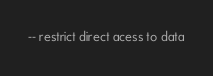Convert code to text. <code><loc_0><loc_0><loc_500><loc_500><_SQL_>-- restrict direct acess to data</code> 